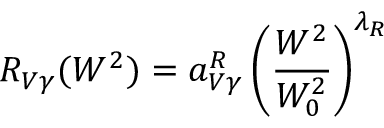Convert formula to latex. <formula><loc_0><loc_0><loc_500><loc_500>R _ { V \gamma } ( W ^ { 2 } ) = a _ { V \gamma } ^ { R } \left ( { \frac { W ^ { 2 } } { W _ { 0 } ^ { 2 } } } \right ) ^ { \lambda _ { R } }</formula> 